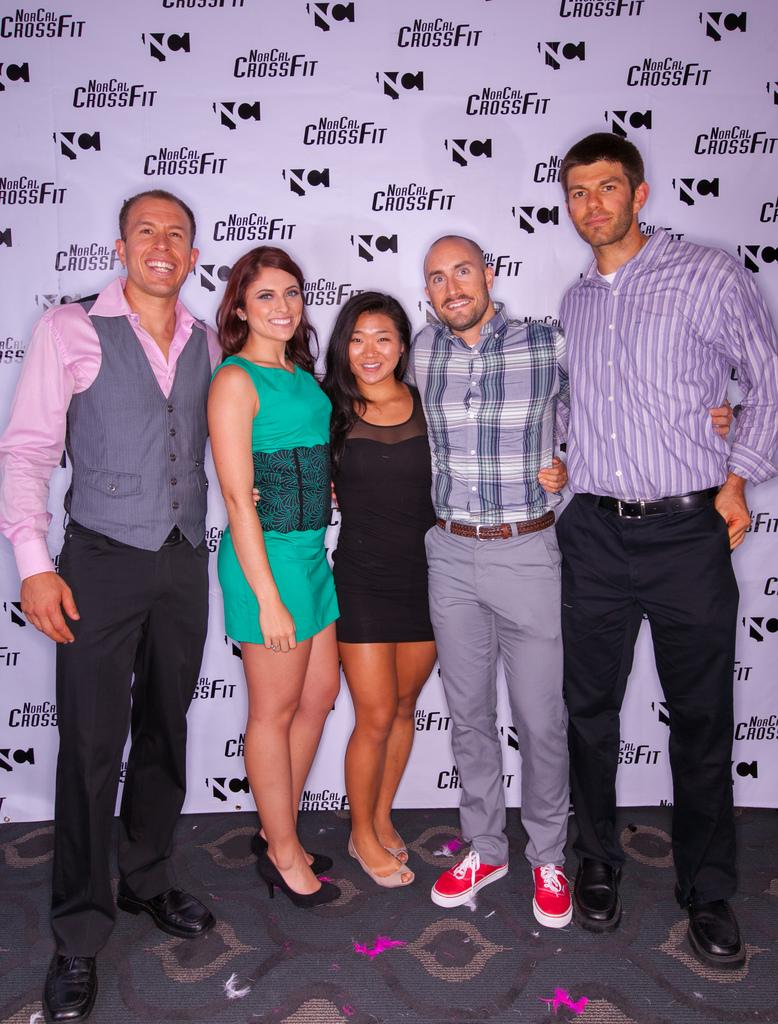What is the main subject of the image? The main subject of the image is a group of people. What are the people in the image doing? The people are standing and smiling. What is the color scheme of the background in the image? The background of the image is black and white. How many feet can be seen in the image? There is no specific mention of feet in the image, so it is not possible to determine how many feet are visible. 